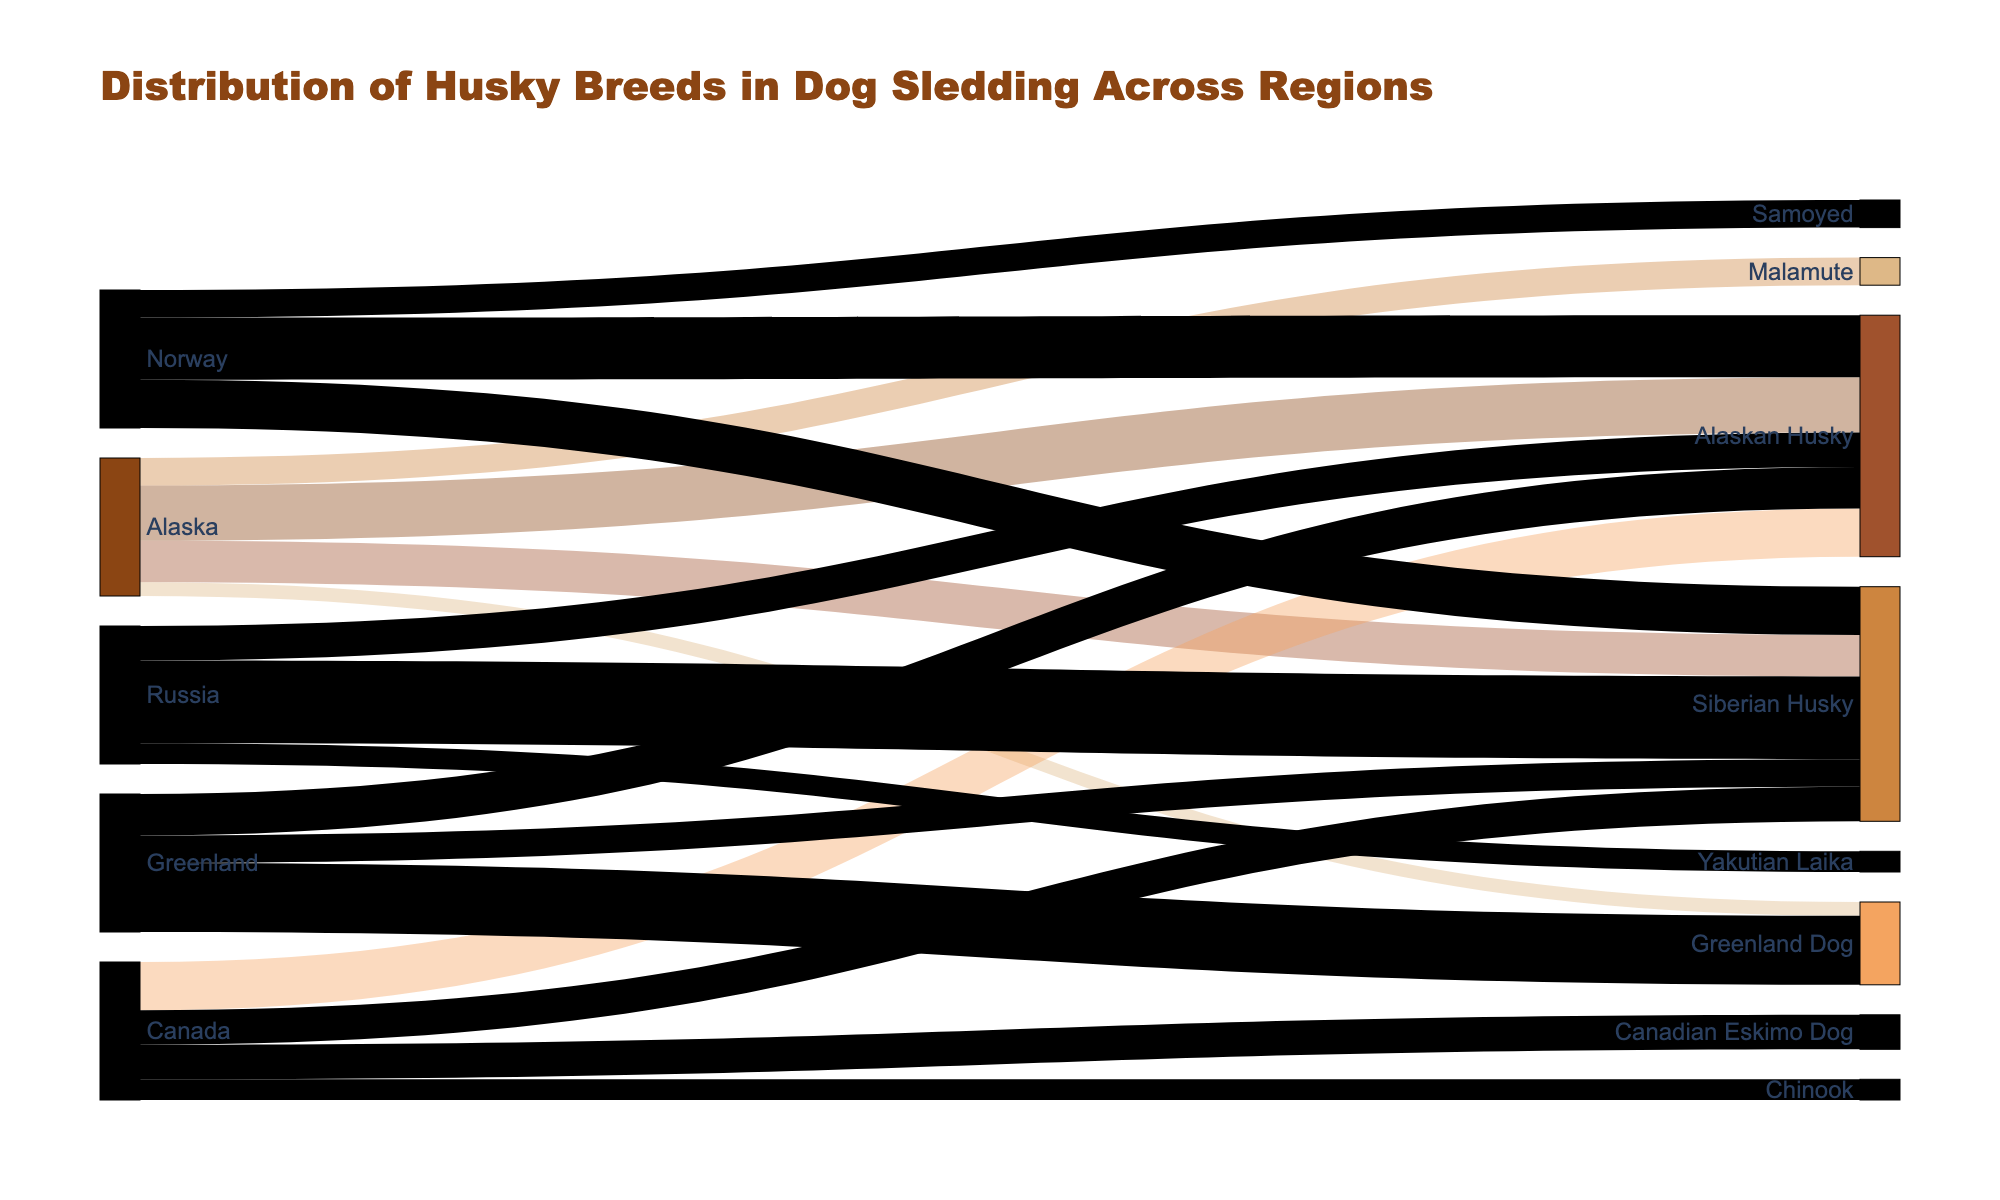What's the most common breed of husky used for dog sledding in Greenland? To find the most common breed used in Greenland, look at the largest flow from the 'Greenland' node. The breed with the highest value connected to Greenland is the Greenland Dog at 50%.
Answer: Greenland Dog Which region has the highest percentage of Siberian Huskies? To determine this, compare the percentage values connected to the Siberian Husky from different regions. Russia has 60%, which is the highest among the regions.
Answer: Russia What is the title of the figure? The title is displayed at the top of the figure and reads "Distribution of Husky Breeds in Dog Sledding Across Regions."
Answer: Distribution of Husky Breeds in Dog Sledding Across Regions How many regions are depicted in the figure? The number of regions can be determined by counting the nodes that represent regions. They are Alaska, Canada, Greenland, Norway, and Russia, making a total of 5 regions.
Answer: 5 What region has the highest diversity of husky breeds shown in the diagram? To find the region with the highest diversity, count the number of different husky breeds connected to each region. Both Alaska and Canada have 4 different breeds, which is the highest diversity.
Answer: Alaska and Canada What percentage of Canadian Eskimo Dogs are used in Canada? The percentage of Canadian Eskimo Dogs used in Canada can be found by looking at the connection from Canada to Canadian Eskimo Dog, which shows 25%.
Answer: 25% Which region uses the Samoyed breed, and what is the percentage? Find the region connected to the Samoyed breed. Norway is the only region using Samoyed with a percentage of 20%.
Answer: Norway with 20% Is the percentage of Alaskan Huskies higher in Alaska or Norway? Compare the percentages of Alaskan Huskies between Alaska and Norway. Alaska is 40%, and Norway is 45%. Therefore, the percentage is higher in Norway.
Answer: Norway What percentage of sled dogs in Russia are Yakutian Laikas? The percentage is found by looking at the connection from Russia to Yakutian Laika, which shows 15%.
Answer: 15% Which breed has the smallest representation in Alaska, and what is the percentage? To find the breed with the smallest representation in Alaska, look for the smallest percentage value linked to Alaska. The Greenland Dog has the smallest representation with 10%.
Answer: Greenland Dog with 10% 